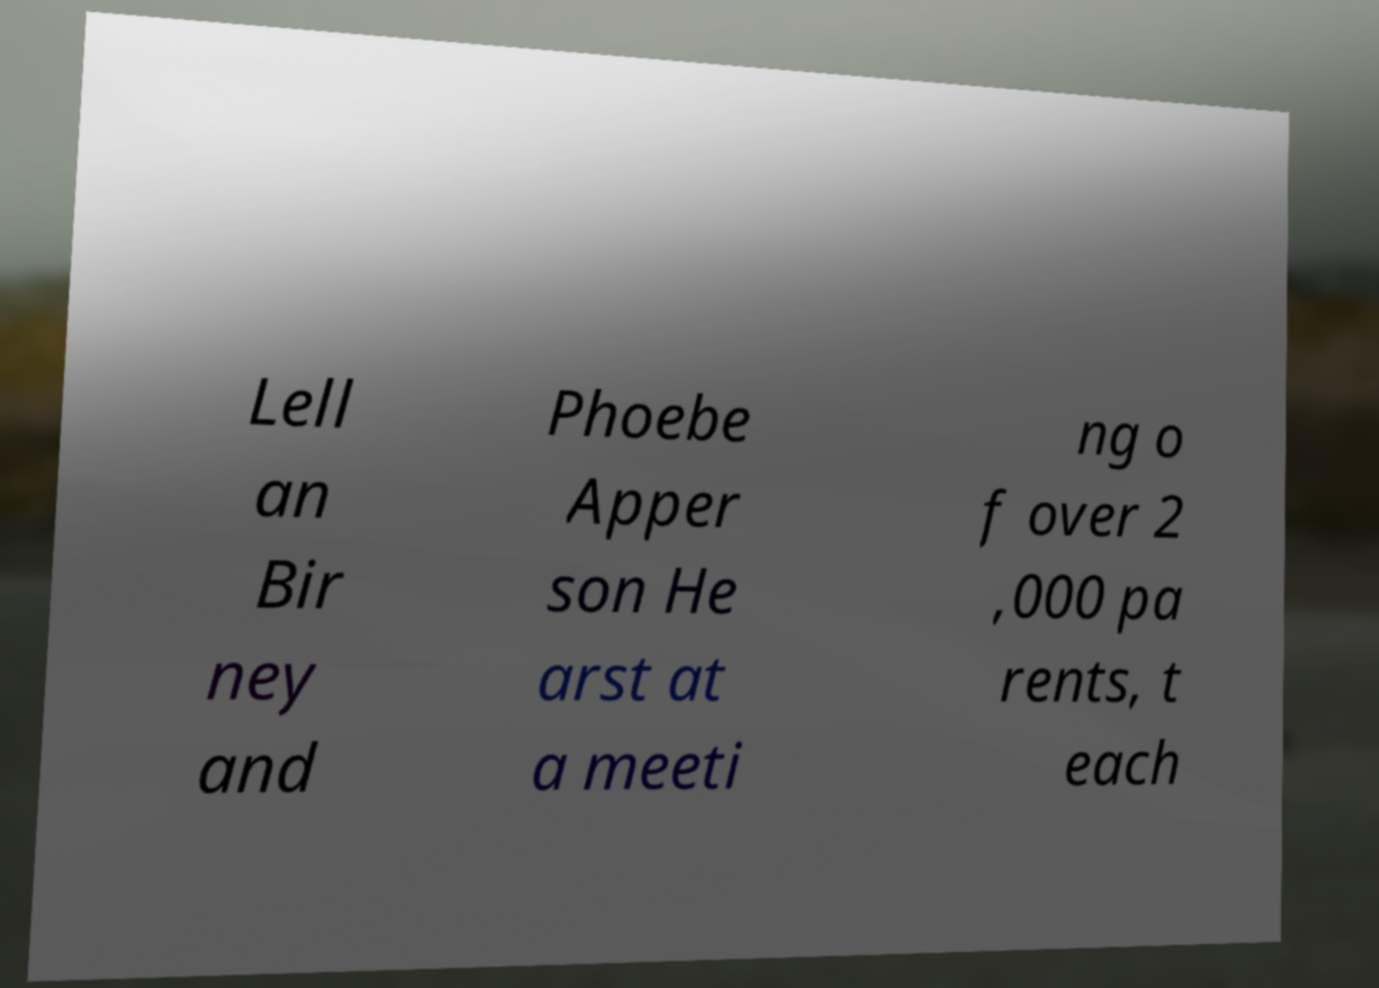Could you assist in decoding the text presented in this image and type it out clearly? Lell an Bir ney and Phoebe Apper son He arst at a meeti ng o f over 2 ,000 pa rents, t each 